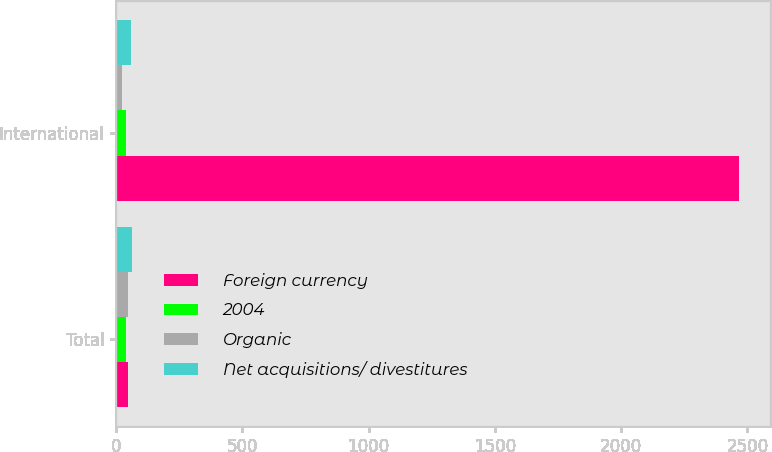Convert chart. <chart><loc_0><loc_0><loc_500><loc_500><stacked_bar_chart><ecel><fcel>Total<fcel>International<nl><fcel>Foreign currency<fcel>46<fcel>2465.9<nl><fcel>2004<fcel>39.5<fcel>39.5<nl><fcel>Organic<fcel>46<fcel>22.9<nl><fcel>Net acquisitions/ divestitures<fcel>64.9<fcel>59.3<nl></chart> 